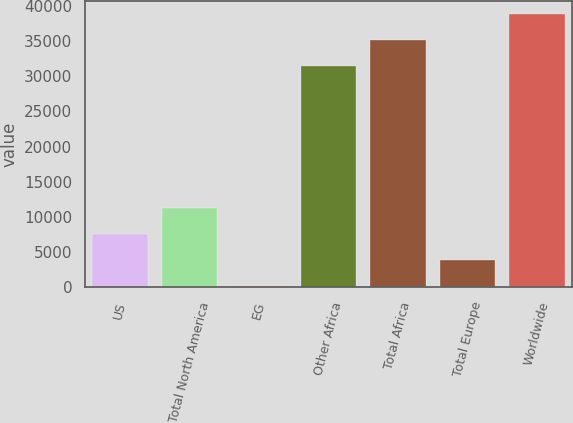<chart> <loc_0><loc_0><loc_500><loc_500><bar_chart><fcel>US<fcel>Total North America<fcel>EG<fcel>Other Africa<fcel>Total Africa<fcel>Total Europe<fcel>Worldwide<nl><fcel>7568.4<fcel>11238.6<fcel>228<fcel>31470<fcel>35140.2<fcel>3898.2<fcel>38810.4<nl></chart> 